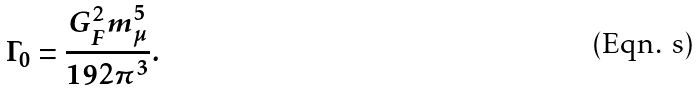Convert formula to latex. <formula><loc_0><loc_0><loc_500><loc_500>\Gamma _ { 0 } = \frac { G _ { F } ^ { 2 } m _ { \mu } ^ { 5 } } { 1 9 2 \pi ^ { 3 } } .</formula> 